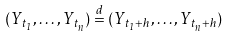Convert formula to latex. <formula><loc_0><loc_0><loc_500><loc_500>( Y _ { t _ { 1 } } , \dots , Y _ { t _ { n } } ) \stackrel { d } { = } ( Y _ { t _ { 1 } + h } , \dots , Y _ { t _ { n } + h } )</formula> 